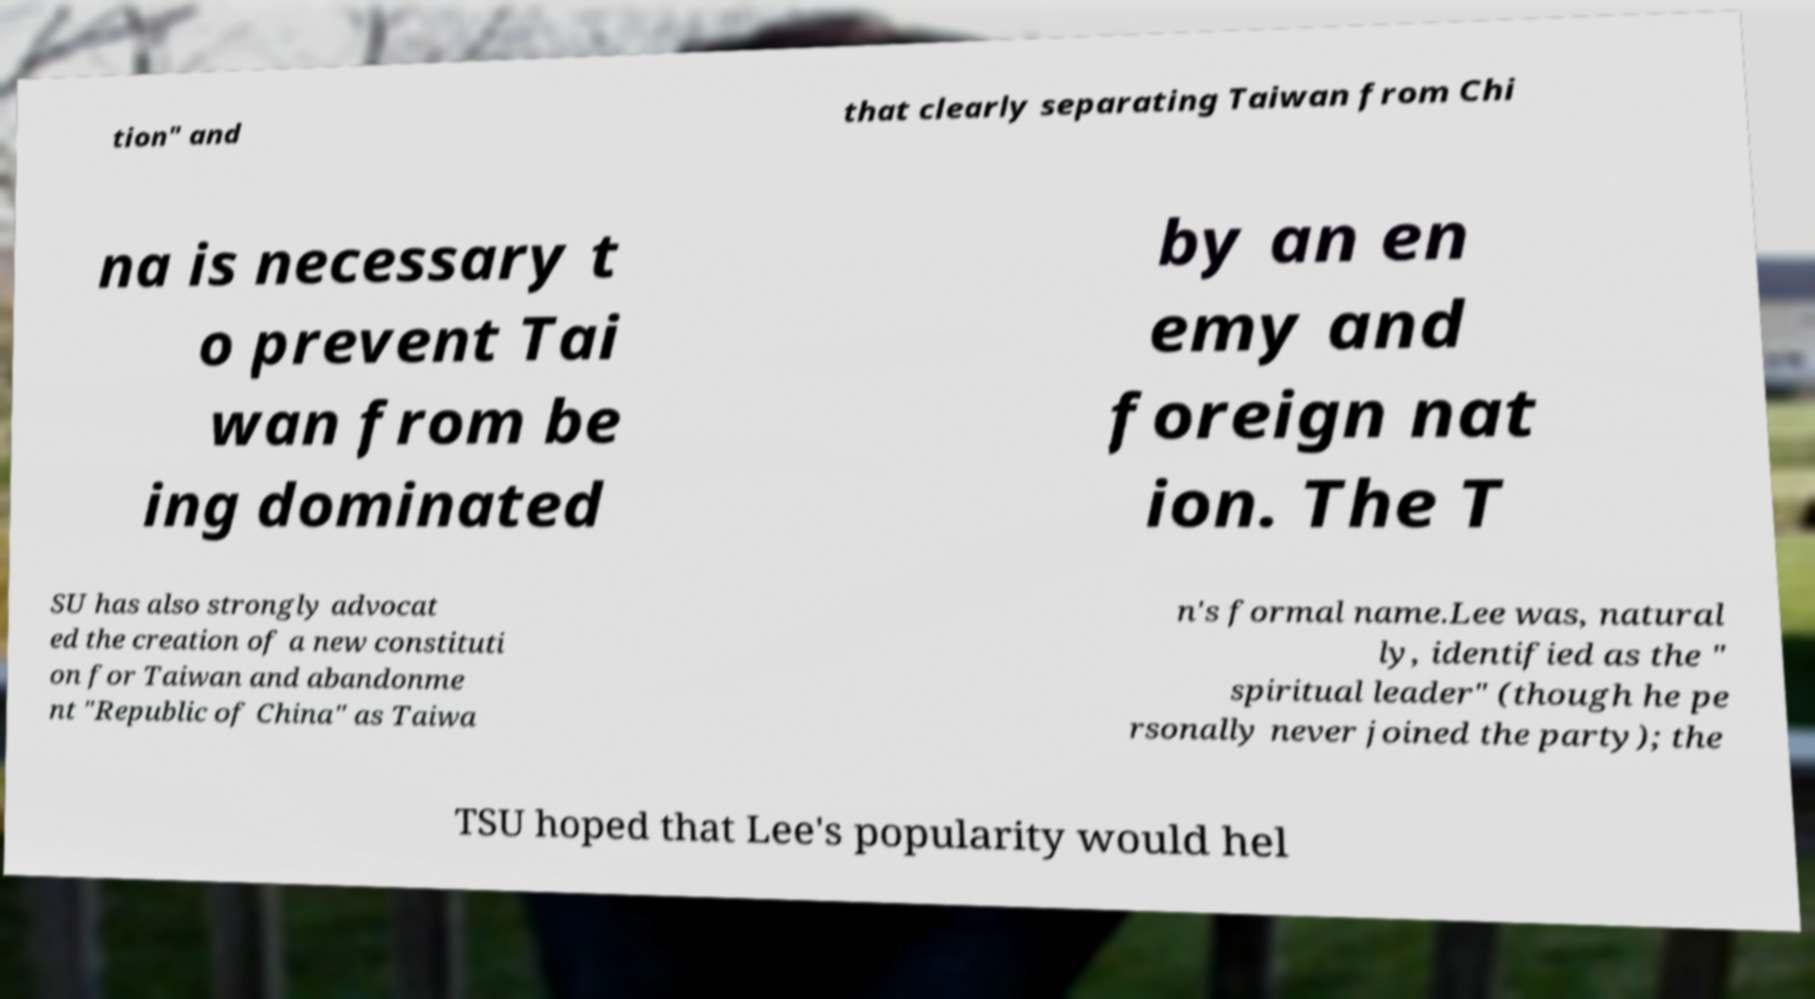I need the written content from this picture converted into text. Can you do that? tion" and that clearly separating Taiwan from Chi na is necessary t o prevent Tai wan from be ing dominated by an en emy and foreign nat ion. The T SU has also strongly advocat ed the creation of a new constituti on for Taiwan and abandonme nt "Republic of China" as Taiwa n's formal name.Lee was, natural ly, identified as the " spiritual leader" (though he pe rsonally never joined the party); the TSU hoped that Lee's popularity would hel 